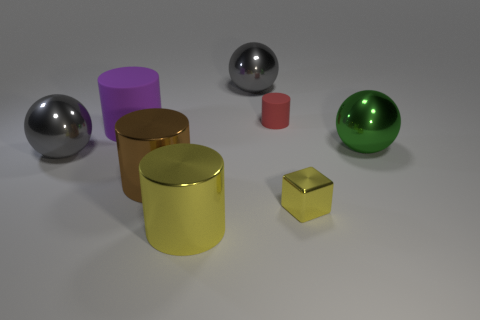Add 1 large yellow objects. How many objects exist? 9 Subtract all cubes. How many objects are left? 7 Subtract all red rubber objects. Subtract all tiny shiny objects. How many objects are left? 6 Add 6 tiny shiny objects. How many tiny shiny objects are left? 7 Add 3 large green balls. How many large green balls exist? 4 Subtract 0 gray cylinders. How many objects are left? 8 